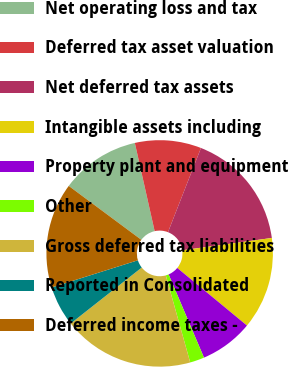Convert chart. <chart><loc_0><loc_0><loc_500><loc_500><pie_chart><fcel>Net operating loss and tax<fcel>Deferred tax asset valuation<fcel>Net deferred tax assets<fcel>Intangible assets including<fcel>Property plant and equipment<fcel>Other<fcel>Gross deferred tax liabilities<fcel>Reported in Consolidated<fcel>Deferred income taxes -<nl><fcel>11.32%<fcel>9.46%<fcel>16.88%<fcel>13.17%<fcel>7.61%<fcel>2.05%<fcel>18.73%<fcel>5.76%<fcel>15.02%<nl></chart> 